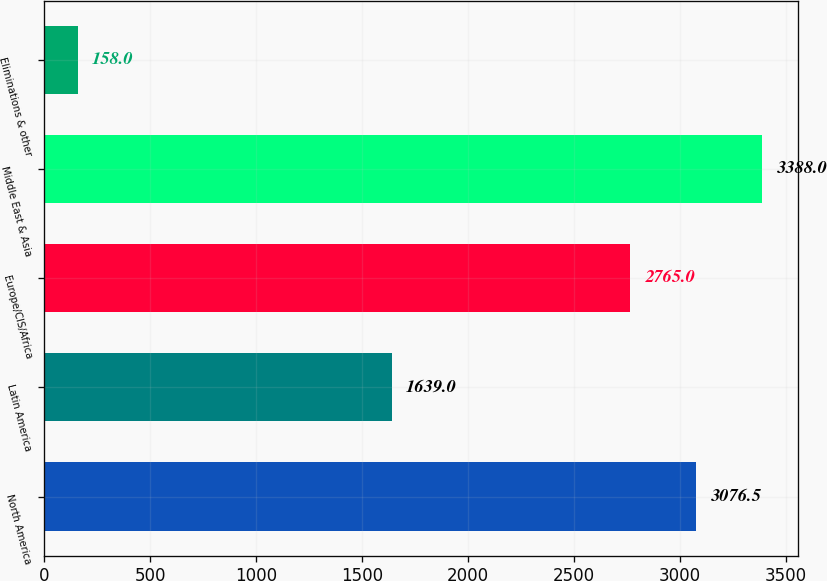<chart> <loc_0><loc_0><loc_500><loc_500><bar_chart><fcel>North America<fcel>Latin America<fcel>Europe/CIS/Africa<fcel>Middle East & Asia<fcel>Eliminations & other<nl><fcel>3076.5<fcel>1639<fcel>2765<fcel>3388<fcel>158<nl></chart> 